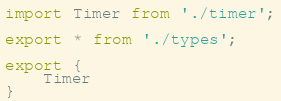Convert code to text. <code><loc_0><loc_0><loc_500><loc_500><_TypeScript_>import Timer from './timer';

export * from './types';

export {
    Timer
}
</code> 